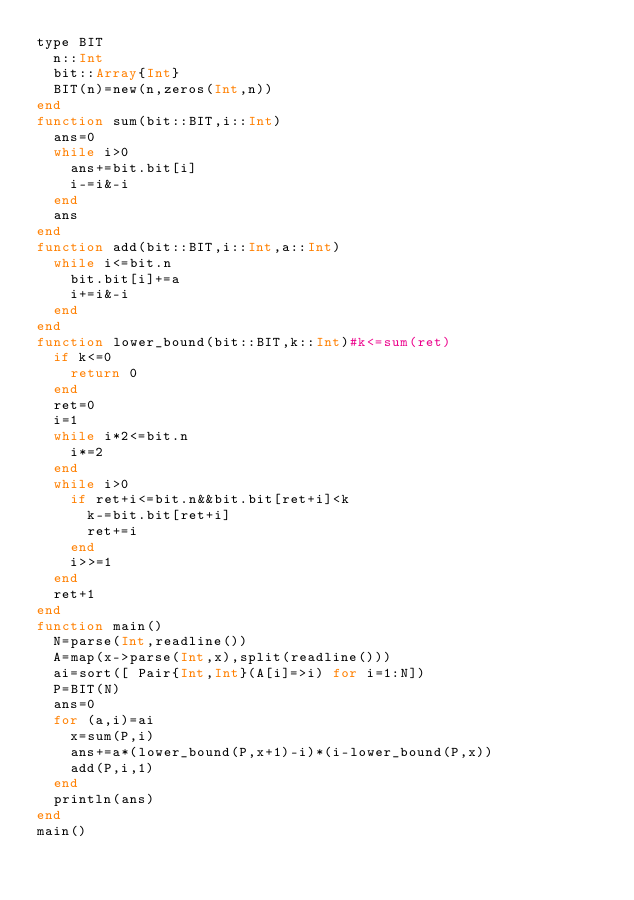Convert code to text. <code><loc_0><loc_0><loc_500><loc_500><_Julia_>type BIT
	n::Int
	bit::Array{Int}
	BIT(n)=new(n,zeros(Int,n))
end
function sum(bit::BIT,i::Int)
	ans=0
	while i>0
		ans+=bit.bit[i]
		i-=i&-i
	end
	ans
end
function add(bit::BIT,i::Int,a::Int)
	while i<=bit.n
		bit.bit[i]+=a
		i+=i&-i
	end
end
function lower_bound(bit::BIT,k::Int)#k<=sum(ret)
	if k<=0
		return 0
	end
	ret=0
	i=1
	while i*2<=bit.n
		i*=2
	end
	while i>0
		if ret+i<=bit.n&&bit.bit[ret+i]<k
			k-=bit.bit[ret+i]
			ret+=i
		end
		i>>=1
	end
	ret+1
end
function main()
	N=parse(Int,readline())
	A=map(x->parse(Int,x),split(readline()))
	ai=sort([ Pair{Int,Int}(A[i]=>i) for i=1:N])
	P=BIT(N)
	ans=0
	for (a,i)=ai
		x=sum(P,i)
		ans+=a*(lower_bound(P,x+1)-i)*(i-lower_bound(P,x))
		add(P,i,1)
	end
	println(ans)
end
main()
</code> 